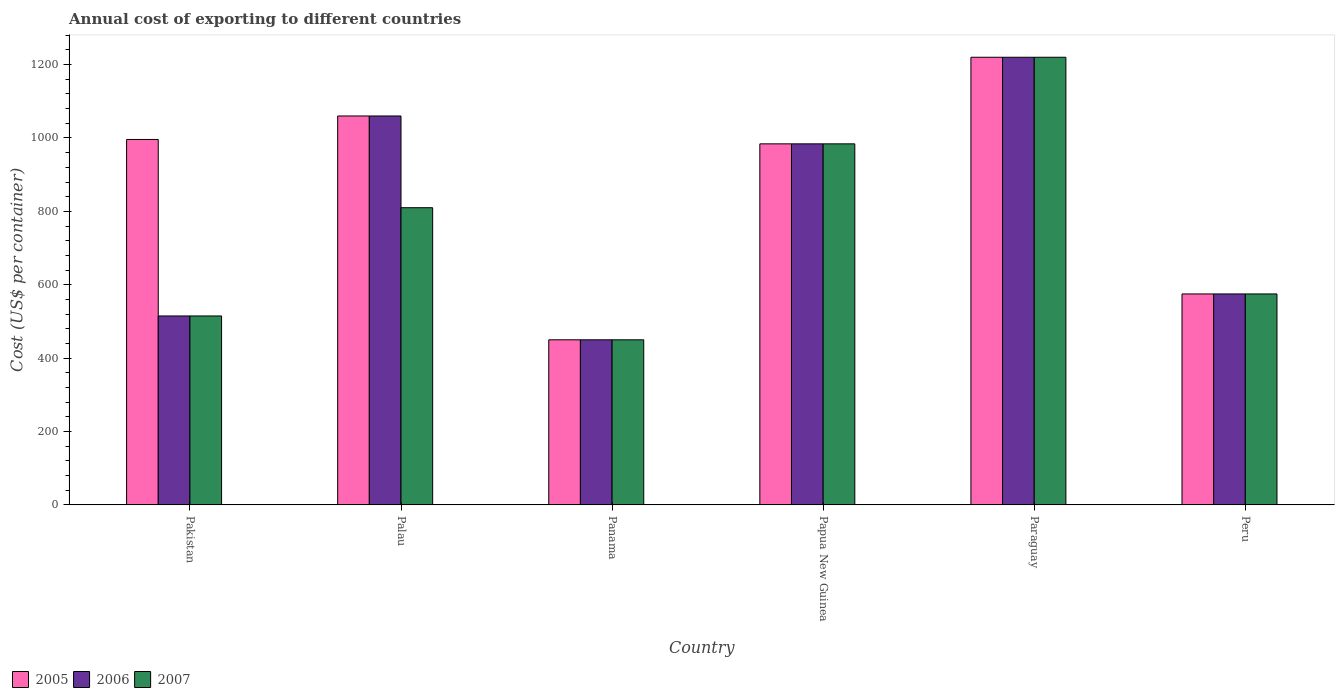How many groups of bars are there?
Offer a terse response. 6. Are the number of bars per tick equal to the number of legend labels?
Offer a terse response. Yes. Are the number of bars on each tick of the X-axis equal?
Your answer should be compact. Yes. How many bars are there on the 2nd tick from the left?
Offer a very short reply. 3. What is the total annual cost of exporting in 2007 in Panama?
Offer a very short reply. 450. Across all countries, what is the maximum total annual cost of exporting in 2007?
Your response must be concise. 1220. Across all countries, what is the minimum total annual cost of exporting in 2006?
Ensure brevity in your answer.  450. In which country was the total annual cost of exporting in 2005 maximum?
Ensure brevity in your answer.  Paraguay. In which country was the total annual cost of exporting in 2006 minimum?
Ensure brevity in your answer.  Panama. What is the total total annual cost of exporting in 2007 in the graph?
Offer a terse response. 4554. What is the difference between the total annual cost of exporting in 2006 in Pakistan and that in Peru?
Provide a succinct answer. -60. What is the difference between the total annual cost of exporting in 2005 in Panama and the total annual cost of exporting in 2006 in Pakistan?
Offer a terse response. -65. What is the average total annual cost of exporting in 2006 per country?
Provide a succinct answer. 800.67. What is the difference between the total annual cost of exporting of/in 2007 and total annual cost of exporting of/in 2005 in Papua New Guinea?
Your answer should be very brief. 0. In how many countries, is the total annual cost of exporting in 2007 greater than 1240 US$?
Offer a terse response. 0. What is the ratio of the total annual cost of exporting in 2005 in Palau to that in Paraguay?
Keep it short and to the point. 0.87. Is the total annual cost of exporting in 2007 in Pakistan less than that in Paraguay?
Give a very brief answer. Yes. What is the difference between the highest and the second highest total annual cost of exporting in 2005?
Your answer should be very brief. 224. What is the difference between the highest and the lowest total annual cost of exporting in 2007?
Offer a very short reply. 770. In how many countries, is the total annual cost of exporting in 2006 greater than the average total annual cost of exporting in 2006 taken over all countries?
Ensure brevity in your answer.  3. What does the 3rd bar from the right in Paraguay represents?
Your answer should be compact. 2005. Is it the case that in every country, the sum of the total annual cost of exporting in 2006 and total annual cost of exporting in 2005 is greater than the total annual cost of exporting in 2007?
Give a very brief answer. Yes. Are all the bars in the graph horizontal?
Provide a succinct answer. No. What is the difference between two consecutive major ticks on the Y-axis?
Make the answer very short. 200. Are the values on the major ticks of Y-axis written in scientific E-notation?
Ensure brevity in your answer.  No. Does the graph contain any zero values?
Your answer should be compact. No. What is the title of the graph?
Provide a short and direct response. Annual cost of exporting to different countries. What is the label or title of the Y-axis?
Offer a terse response. Cost (US$ per container). What is the Cost (US$ per container) of 2005 in Pakistan?
Your answer should be compact. 996. What is the Cost (US$ per container) of 2006 in Pakistan?
Your answer should be compact. 515. What is the Cost (US$ per container) of 2007 in Pakistan?
Your answer should be very brief. 515. What is the Cost (US$ per container) in 2005 in Palau?
Give a very brief answer. 1060. What is the Cost (US$ per container) in 2006 in Palau?
Your answer should be very brief. 1060. What is the Cost (US$ per container) of 2007 in Palau?
Give a very brief answer. 810. What is the Cost (US$ per container) of 2005 in Panama?
Your answer should be very brief. 450. What is the Cost (US$ per container) of 2006 in Panama?
Ensure brevity in your answer.  450. What is the Cost (US$ per container) in 2007 in Panama?
Give a very brief answer. 450. What is the Cost (US$ per container) of 2005 in Papua New Guinea?
Offer a terse response. 984. What is the Cost (US$ per container) in 2006 in Papua New Guinea?
Offer a terse response. 984. What is the Cost (US$ per container) of 2007 in Papua New Guinea?
Offer a terse response. 984. What is the Cost (US$ per container) of 2005 in Paraguay?
Offer a very short reply. 1220. What is the Cost (US$ per container) in 2006 in Paraguay?
Your response must be concise. 1220. What is the Cost (US$ per container) in 2007 in Paraguay?
Your response must be concise. 1220. What is the Cost (US$ per container) in 2005 in Peru?
Make the answer very short. 575. What is the Cost (US$ per container) in 2006 in Peru?
Provide a short and direct response. 575. What is the Cost (US$ per container) of 2007 in Peru?
Give a very brief answer. 575. Across all countries, what is the maximum Cost (US$ per container) in 2005?
Ensure brevity in your answer.  1220. Across all countries, what is the maximum Cost (US$ per container) in 2006?
Provide a succinct answer. 1220. Across all countries, what is the maximum Cost (US$ per container) of 2007?
Make the answer very short. 1220. Across all countries, what is the minimum Cost (US$ per container) of 2005?
Offer a very short reply. 450. Across all countries, what is the minimum Cost (US$ per container) of 2006?
Provide a succinct answer. 450. Across all countries, what is the minimum Cost (US$ per container) in 2007?
Offer a terse response. 450. What is the total Cost (US$ per container) in 2005 in the graph?
Give a very brief answer. 5285. What is the total Cost (US$ per container) of 2006 in the graph?
Give a very brief answer. 4804. What is the total Cost (US$ per container) in 2007 in the graph?
Offer a terse response. 4554. What is the difference between the Cost (US$ per container) of 2005 in Pakistan and that in Palau?
Keep it short and to the point. -64. What is the difference between the Cost (US$ per container) in 2006 in Pakistan and that in Palau?
Provide a succinct answer. -545. What is the difference between the Cost (US$ per container) in 2007 in Pakistan and that in Palau?
Keep it short and to the point. -295. What is the difference between the Cost (US$ per container) in 2005 in Pakistan and that in Panama?
Offer a very short reply. 546. What is the difference between the Cost (US$ per container) in 2005 in Pakistan and that in Papua New Guinea?
Your answer should be very brief. 12. What is the difference between the Cost (US$ per container) in 2006 in Pakistan and that in Papua New Guinea?
Your response must be concise. -469. What is the difference between the Cost (US$ per container) of 2007 in Pakistan and that in Papua New Guinea?
Offer a very short reply. -469. What is the difference between the Cost (US$ per container) in 2005 in Pakistan and that in Paraguay?
Provide a succinct answer. -224. What is the difference between the Cost (US$ per container) in 2006 in Pakistan and that in Paraguay?
Provide a succinct answer. -705. What is the difference between the Cost (US$ per container) in 2007 in Pakistan and that in Paraguay?
Provide a short and direct response. -705. What is the difference between the Cost (US$ per container) of 2005 in Pakistan and that in Peru?
Offer a terse response. 421. What is the difference between the Cost (US$ per container) of 2006 in Pakistan and that in Peru?
Your answer should be compact. -60. What is the difference between the Cost (US$ per container) of 2007 in Pakistan and that in Peru?
Make the answer very short. -60. What is the difference between the Cost (US$ per container) of 2005 in Palau and that in Panama?
Offer a very short reply. 610. What is the difference between the Cost (US$ per container) of 2006 in Palau and that in Panama?
Offer a terse response. 610. What is the difference between the Cost (US$ per container) of 2007 in Palau and that in Panama?
Ensure brevity in your answer.  360. What is the difference between the Cost (US$ per container) in 2005 in Palau and that in Papua New Guinea?
Keep it short and to the point. 76. What is the difference between the Cost (US$ per container) of 2007 in Palau and that in Papua New Guinea?
Your answer should be very brief. -174. What is the difference between the Cost (US$ per container) of 2005 in Palau and that in Paraguay?
Your response must be concise. -160. What is the difference between the Cost (US$ per container) in 2006 in Palau and that in Paraguay?
Keep it short and to the point. -160. What is the difference between the Cost (US$ per container) in 2007 in Palau and that in Paraguay?
Keep it short and to the point. -410. What is the difference between the Cost (US$ per container) of 2005 in Palau and that in Peru?
Your answer should be very brief. 485. What is the difference between the Cost (US$ per container) in 2006 in Palau and that in Peru?
Your answer should be compact. 485. What is the difference between the Cost (US$ per container) of 2007 in Palau and that in Peru?
Ensure brevity in your answer.  235. What is the difference between the Cost (US$ per container) in 2005 in Panama and that in Papua New Guinea?
Your answer should be very brief. -534. What is the difference between the Cost (US$ per container) in 2006 in Panama and that in Papua New Guinea?
Ensure brevity in your answer.  -534. What is the difference between the Cost (US$ per container) of 2007 in Panama and that in Papua New Guinea?
Keep it short and to the point. -534. What is the difference between the Cost (US$ per container) of 2005 in Panama and that in Paraguay?
Keep it short and to the point. -770. What is the difference between the Cost (US$ per container) of 2006 in Panama and that in Paraguay?
Your answer should be compact. -770. What is the difference between the Cost (US$ per container) of 2007 in Panama and that in Paraguay?
Make the answer very short. -770. What is the difference between the Cost (US$ per container) in 2005 in Panama and that in Peru?
Give a very brief answer. -125. What is the difference between the Cost (US$ per container) of 2006 in Panama and that in Peru?
Make the answer very short. -125. What is the difference between the Cost (US$ per container) in 2007 in Panama and that in Peru?
Provide a succinct answer. -125. What is the difference between the Cost (US$ per container) of 2005 in Papua New Guinea and that in Paraguay?
Make the answer very short. -236. What is the difference between the Cost (US$ per container) in 2006 in Papua New Guinea and that in Paraguay?
Your answer should be compact. -236. What is the difference between the Cost (US$ per container) of 2007 in Papua New Guinea and that in Paraguay?
Give a very brief answer. -236. What is the difference between the Cost (US$ per container) of 2005 in Papua New Guinea and that in Peru?
Offer a very short reply. 409. What is the difference between the Cost (US$ per container) in 2006 in Papua New Guinea and that in Peru?
Offer a very short reply. 409. What is the difference between the Cost (US$ per container) in 2007 in Papua New Guinea and that in Peru?
Offer a terse response. 409. What is the difference between the Cost (US$ per container) in 2005 in Paraguay and that in Peru?
Your response must be concise. 645. What is the difference between the Cost (US$ per container) in 2006 in Paraguay and that in Peru?
Your answer should be compact. 645. What is the difference between the Cost (US$ per container) in 2007 in Paraguay and that in Peru?
Your answer should be compact. 645. What is the difference between the Cost (US$ per container) of 2005 in Pakistan and the Cost (US$ per container) of 2006 in Palau?
Make the answer very short. -64. What is the difference between the Cost (US$ per container) in 2005 in Pakistan and the Cost (US$ per container) in 2007 in Palau?
Offer a terse response. 186. What is the difference between the Cost (US$ per container) in 2006 in Pakistan and the Cost (US$ per container) in 2007 in Palau?
Offer a terse response. -295. What is the difference between the Cost (US$ per container) in 2005 in Pakistan and the Cost (US$ per container) in 2006 in Panama?
Provide a short and direct response. 546. What is the difference between the Cost (US$ per container) in 2005 in Pakistan and the Cost (US$ per container) in 2007 in Panama?
Keep it short and to the point. 546. What is the difference between the Cost (US$ per container) in 2005 in Pakistan and the Cost (US$ per container) in 2006 in Papua New Guinea?
Provide a short and direct response. 12. What is the difference between the Cost (US$ per container) of 2006 in Pakistan and the Cost (US$ per container) of 2007 in Papua New Guinea?
Your answer should be compact. -469. What is the difference between the Cost (US$ per container) of 2005 in Pakistan and the Cost (US$ per container) of 2006 in Paraguay?
Give a very brief answer. -224. What is the difference between the Cost (US$ per container) in 2005 in Pakistan and the Cost (US$ per container) in 2007 in Paraguay?
Give a very brief answer. -224. What is the difference between the Cost (US$ per container) in 2006 in Pakistan and the Cost (US$ per container) in 2007 in Paraguay?
Your answer should be very brief. -705. What is the difference between the Cost (US$ per container) in 2005 in Pakistan and the Cost (US$ per container) in 2006 in Peru?
Offer a very short reply. 421. What is the difference between the Cost (US$ per container) in 2005 in Pakistan and the Cost (US$ per container) in 2007 in Peru?
Offer a very short reply. 421. What is the difference between the Cost (US$ per container) in 2006 in Pakistan and the Cost (US$ per container) in 2007 in Peru?
Ensure brevity in your answer.  -60. What is the difference between the Cost (US$ per container) in 2005 in Palau and the Cost (US$ per container) in 2006 in Panama?
Provide a succinct answer. 610. What is the difference between the Cost (US$ per container) in 2005 in Palau and the Cost (US$ per container) in 2007 in Panama?
Your answer should be compact. 610. What is the difference between the Cost (US$ per container) of 2006 in Palau and the Cost (US$ per container) of 2007 in Panama?
Offer a very short reply. 610. What is the difference between the Cost (US$ per container) in 2005 in Palau and the Cost (US$ per container) in 2006 in Papua New Guinea?
Your answer should be very brief. 76. What is the difference between the Cost (US$ per container) in 2005 in Palau and the Cost (US$ per container) in 2007 in Papua New Guinea?
Ensure brevity in your answer.  76. What is the difference between the Cost (US$ per container) of 2006 in Palau and the Cost (US$ per container) of 2007 in Papua New Guinea?
Keep it short and to the point. 76. What is the difference between the Cost (US$ per container) of 2005 in Palau and the Cost (US$ per container) of 2006 in Paraguay?
Offer a terse response. -160. What is the difference between the Cost (US$ per container) in 2005 in Palau and the Cost (US$ per container) in 2007 in Paraguay?
Your response must be concise. -160. What is the difference between the Cost (US$ per container) of 2006 in Palau and the Cost (US$ per container) of 2007 in Paraguay?
Keep it short and to the point. -160. What is the difference between the Cost (US$ per container) of 2005 in Palau and the Cost (US$ per container) of 2006 in Peru?
Your answer should be very brief. 485. What is the difference between the Cost (US$ per container) in 2005 in Palau and the Cost (US$ per container) in 2007 in Peru?
Give a very brief answer. 485. What is the difference between the Cost (US$ per container) in 2006 in Palau and the Cost (US$ per container) in 2007 in Peru?
Keep it short and to the point. 485. What is the difference between the Cost (US$ per container) of 2005 in Panama and the Cost (US$ per container) of 2006 in Papua New Guinea?
Provide a succinct answer. -534. What is the difference between the Cost (US$ per container) of 2005 in Panama and the Cost (US$ per container) of 2007 in Papua New Guinea?
Your answer should be compact. -534. What is the difference between the Cost (US$ per container) of 2006 in Panama and the Cost (US$ per container) of 2007 in Papua New Guinea?
Offer a terse response. -534. What is the difference between the Cost (US$ per container) of 2005 in Panama and the Cost (US$ per container) of 2006 in Paraguay?
Your answer should be very brief. -770. What is the difference between the Cost (US$ per container) in 2005 in Panama and the Cost (US$ per container) in 2007 in Paraguay?
Provide a succinct answer. -770. What is the difference between the Cost (US$ per container) of 2006 in Panama and the Cost (US$ per container) of 2007 in Paraguay?
Your answer should be compact. -770. What is the difference between the Cost (US$ per container) in 2005 in Panama and the Cost (US$ per container) in 2006 in Peru?
Offer a very short reply. -125. What is the difference between the Cost (US$ per container) in 2005 in Panama and the Cost (US$ per container) in 2007 in Peru?
Your answer should be very brief. -125. What is the difference between the Cost (US$ per container) in 2006 in Panama and the Cost (US$ per container) in 2007 in Peru?
Your answer should be very brief. -125. What is the difference between the Cost (US$ per container) in 2005 in Papua New Guinea and the Cost (US$ per container) in 2006 in Paraguay?
Keep it short and to the point. -236. What is the difference between the Cost (US$ per container) in 2005 in Papua New Guinea and the Cost (US$ per container) in 2007 in Paraguay?
Provide a short and direct response. -236. What is the difference between the Cost (US$ per container) in 2006 in Papua New Guinea and the Cost (US$ per container) in 2007 in Paraguay?
Make the answer very short. -236. What is the difference between the Cost (US$ per container) in 2005 in Papua New Guinea and the Cost (US$ per container) in 2006 in Peru?
Your answer should be very brief. 409. What is the difference between the Cost (US$ per container) of 2005 in Papua New Guinea and the Cost (US$ per container) of 2007 in Peru?
Provide a succinct answer. 409. What is the difference between the Cost (US$ per container) of 2006 in Papua New Guinea and the Cost (US$ per container) of 2007 in Peru?
Give a very brief answer. 409. What is the difference between the Cost (US$ per container) of 2005 in Paraguay and the Cost (US$ per container) of 2006 in Peru?
Make the answer very short. 645. What is the difference between the Cost (US$ per container) in 2005 in Paraguay and the Cost (US$ per container) in 2007 in Peru?
Make the answer very short. 645. What is the difference between the Cost (US$ per container) in 2006 in Paraguay and the Cost (US$ per container) in 2007 in Peru?
Provide a succinct answer. 645. What is the average Cost (US$ per container) of 2005 per country?
Offer a terse response. 880.83. What is the average Cost (US$ per container) in 2006 per country?
Offer a terse response. 800.67. What is the average Cost (US$ per container) of 2007 per country?
Ensure brevity in your answer.  759. What is the difference between the Cost (US$ per container) in 2005 and Cost (US$ per container) in 2006 in Pakistan?
Your answer should be very brief. 481. What is the difference between the Cost (US$ per container) of 2005 and Cost (US$ per container) of 2007 in Pakistan?
Offer a terse response. 481. What is the difference between the Cost (US$ per container) in 2005 and Cost (US$ per container) in 2007 in Palau?
Your response must be concise. 250. What is the difference between the Cost (US$ per container) of 2006 and Cost (US$ per container) of 2007 in Palau?
Ensure brevity in your answer.  250. What is the difference between the Cost (US$ per container) of 2005 and Cost (US$ per container) of 2007 in Panama?
Offer a very short reply. 0. What is the difference between the Cost (US$ per container) in 2006 and Cost (US$ per container) in 2007 in Panama?
Provide a succinct answer. 0. What is the difference between the Cost (US$ per container) of 2005 and Cost (US$ per container) of 2006 in Papua New Guinea?
Your response must be concise. 0. What is the difference between the Cost (US$ per container) in 2006 and Cost (US$ per container) in 2007 in Papua New Guinea?
Your answer should be compact. 0. What is the difference between the Cost (US$ per container) of 2005 and Cost (US$ per container) of 2007 in Paraguay?
Offer a terse response. 0. What is the difference between the Cost (US$ per container) in 2005 and Cost (US$ per container) in 2006 in Peru?
Make the answer very short. 0. What is the difference between the Cost (US$ per container) in 2006 and Cost (US$ per container) in 2007 in Peru?
Provide a succinct answer. 0. What is the ratio of the Cost (US$ per container) of 2005 in Pakistan to that in Palau?
Give a very brief answer. 0.94. What is the ratio of the Cost (US$ per container) of 2006 in Pakistan to that in Palau?
Your answer should be very brief. 0.49. What is the ratio of the Cost (US$ per container) in 2007 in Pakistan to that in Palau?
Your response must be concise. 0.64. What is the ratio of the Cost (US$ per container) in 2005 in Pakistan to that in Panama?
Your answer should be very brief. 2.21. What is the ratio of the Cost (US$ per container) in 2006 in Pakistan to that in Panama?
Make the answer very short. 1.14. What is the ratio of the Cost (US$ per container) of 2007 in Pakistan to that in Panama?
Your answer should be very brief. 1.14. What is the ratio of the Cost (US$ per container) of 2005 in Pakistan to that in Papua New Guinea?
Offer a very short reply. 1.01. What is the ratio of the Cost (US$ per container) in 2006 in Pakistan to that in Papua New Guinea?
Your answer should be very brief. 0.52. What is the ratio of the Cost (US$ per container) of 2007 in Pakistan to that in Papua New Guinea?
Keep it short and to the point. 0.52. What is the ratio of the Cost (US$ per container) in 2005 in Pakistan to that in Paraguay?
Ensure brevity in your answer.  0.82. What is the ratio of the Cost (US$ per container) in 2006 in Pakistan to that in Paraguay?
Your answer should be compact. 0.42. What is the ratio of the Cost (US$ per container) of 2007 in Pakistan to that in Paraguay?
Your answer should be compact. 0.42. What is the ratio of the Cost (US$ per container) in 2005 in Pakistan to that in Peru?
Make the answer very short. 1.73. What is the ratio of the Cost (US$ per container) of 2006 in Pakistan to that in Peru?
Provide a short and direct response. 0.9. What is the ratio of the Cost (US$ per container) of 2007 in Pakistan to that in Peru?
Make the answer very short. 0.9. What is the ratio of the Cost (US$ per container) of 2005 in Palau to that in Panama?
Give a very brief answer. 2.36. What is the ratio of the Cost (US$ per container) of 2006 in Palau to that in Panama?
Make the answer very short. 2.36. What is the ratio of the Cost (US$ per container) in 2007 in Palau to that in Panama?
Your answer should be compact. 1.8. What is the ratio of the Cost (US$ per container) in 2005 in Palau to that in Papua New Guinea?
Provide a short and direct response. 1.08. What is the ratio of the Cost (US$ per container) in 2006 in Palau to that in Papua New Guinea?
Offer a terse response. 1.08. What is the ratio of the Cost (US$ per container) of 2007 in Palau to that in Papua New Guinea?
Give a very brief answer. 0.82. What is the ratio of the Cost (US$ per container) of 2005 in Palau to that in Paraguay?
Give a very brief answer. 0.87. What is the ratio of the Cost (US$ per container) in 2006 in Palau to that in Paraguay?
Provide a short and direct response. 0.87. What is the ratio of the Cost (US$ per container) in 2007 in Palau to that in Paraguay?
Your answer should be very brief. 0.66. What is the ratio of the Cost (US$ per container) in 2005 in Palau to that in Peru?
Your answer should be compact. 1.84. What is the ratio of the Cost (US$ per container) in 2006 in Palau to that in Peru?
Make the answer very short. 1.84. What is the ratio of the Cost (US$ per container) of 2007 in Palau to that in Peru?
Give a very brief answer. 1.41. What is the ratio of the Cost (US$ per container) in 2005 in Panama to that in Papua New Guinea?
Your response must be concise. 0.46. What is the ratio of the Cost (US$ per container) in 2006 in Panama to that in Papua New Guinea?
Make the answer very short. 0.46. What is the ratio of the Cost (US$ per container) in 2007 in Panama to that in Papua New Guinea?
Make the answer very short. 0.46. What is the ratio of the Cost (US$ per container) of 2005 in Panama to that in Paraguay?
Provide a short and direct response. 0.37. What is the ratio of the Cost (US$ per container) in 2006 in Panama to that in Paraguay?
Ensure brevity in your answer.  0.37. What is the ratio of the Cost (US$ per container) of 2007 in Panama to that in Paraguay?
Keep it short and to the point. 0.37. What is the ratio of the Cost (US$ per container) of 2005 in Panama to that in Peru?
Your response must be concise. 0.78. What is the ratio of the Cost (US$ per container) in 2006 in Panama to that in Peru?
Make the answer very short. 0.78. What is the ratio of the Cost (US$ per container) in 2007 in Panama to that in Peru?
Give a very brief answer. 0.78. What is the ratio of the Cost (US$ per container) of 2005 in Papua New Guinea to that in Paraguay?
Keep it short and to the point. 0.81. What is the ratio of the Cost (US$ per container) of 2006 in Papua New Guinea to that in Paraguay?
Offer a very short reply. 0.81. What is the ratio of the Cost (US$ per container) in 2007 in Papua New Guinea to that in Paraguay?
Your answer should be very brief. 0.81. What is the ratio of the Cost (US$ per container) in 2005 in Papua New Guinea to that in Peru?
Offer a terse response. 1.71. What is the ratio of the Cost (US$ per container) of 2006 in Papua New Guinea to that in Peru?
Keep it short and to the point. 1.71. What is the ratio of the Cost (US$ per container) of 2007 in Papua New Guinea to that in Peru?
Ensure brevity in your answer.  1.71. What is the ratio of the Cost (US$ per container) of 2005 in Paraguay to that in Peru?
Provide a short and direct response. 2.12. What is the ratio of the Cost (US$ per container) in 2006 in Paraguay to that in Peru?
Ensure brevity in your answer.  2.12. What is the ratio of the Cost (US$ per container) of 2007 in Paraguay to that in Peru?
Provide a short and direct response. 2.12. What is the difference between the highest and the second highest Cost (US$ per container) of 2005?
Give a very brief answer. 160. What is the difference between the highest and the second highest Cost (US$ per container) of 2006?
Ensure brevity in your answer.  160. What is the difference between the highest and the second highest Cost (US$ per container) of 2007?
Offer a very short reply. 236. What is the difference between the highest and the lowest Cost (US$ per container) in 2005?
Ensure brevity in your answer.  770. What is the difference between the highest and the lowest Cost (US$ per container) of 2006?
Your response must be concise. 770. What is the difference between the highest and the lowest Cost (US$ per container) in 2007?
Ensure brevity in your answer.  770. 